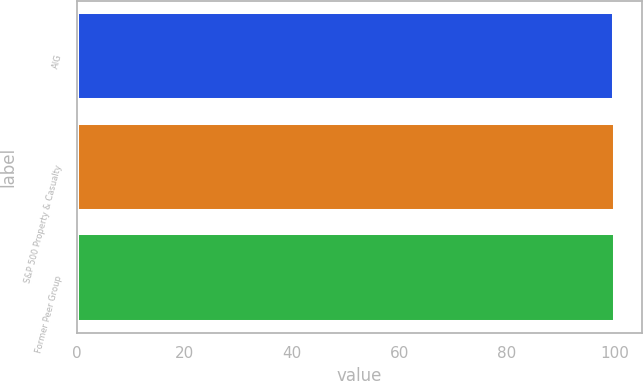Convert chart. <chart><loc_0><loc_0><loc_500><loc_500><bar_chart><fcel>AIG<fcel>S&P 500 Property & Casualty<fcel>Former Peer Group<nl><fcel>100<fcel>100.1<fcel>100.2<nl></chart> 